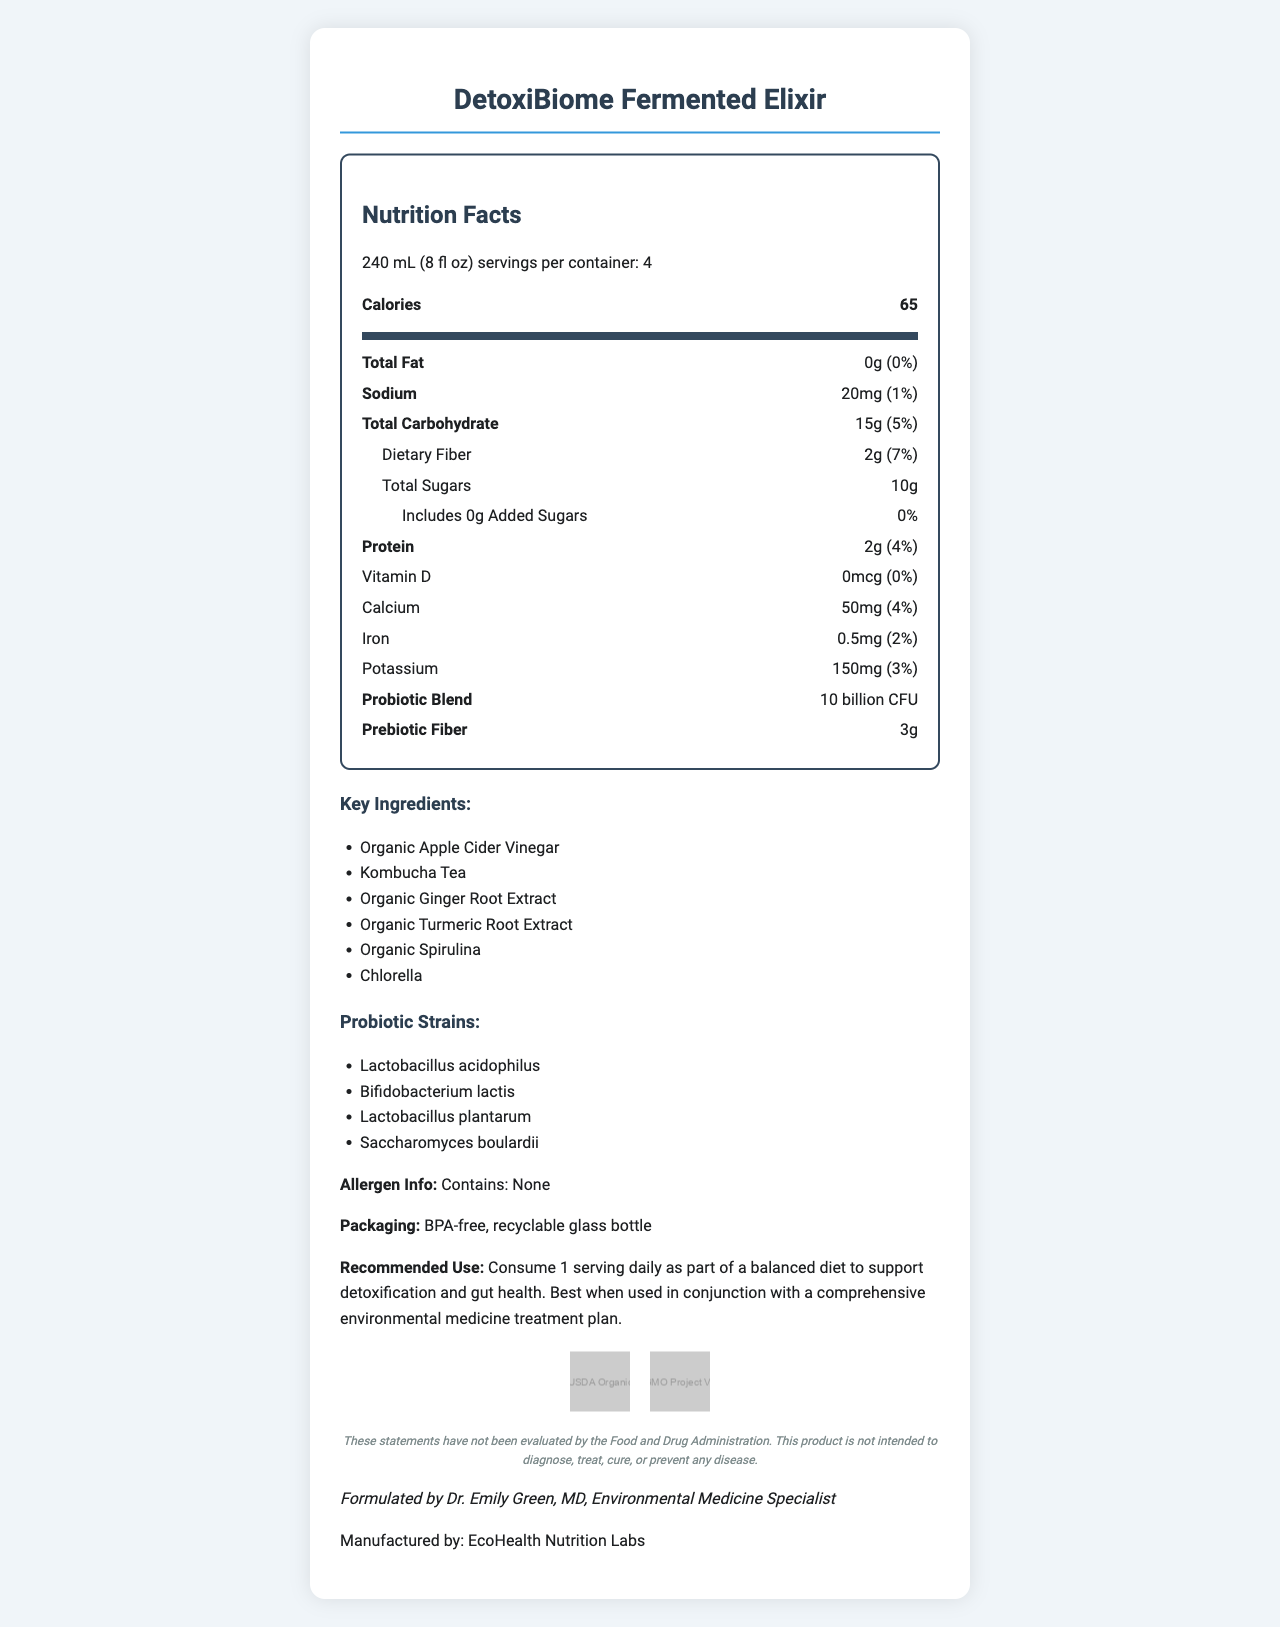what is the serving size? The serving size is listed as "240 mL (8 fl oz)" under the Nutrition Facts section.
Answer: 240 mL (8 fl oz) how many servings are there per container? The document states "servings per container: 4" at the beginning of the Nutrition Facts section.
Answer: 4 how many calories are in one serving? The calories per serving are given as 65.
Answer: 65 what is the amount of total fat per serving? The quantity of total fat per serving is provided as "0g".
Answer: 0g which probiotic strains are included in the blend? The document lists the probiotic strains under the Probiotic Blend section.
Answer: Lactobacillus acidophilus, Bifidobacterium lactis, Lactobacillus plantarum, Saccharomyces boulardii what is the source of prebiotic fiber? A. Inulin (from chicory root) B. Fructooligosaccharides C. Galactooligosaccharides D. Pectin The source of prebiotic fiber is given as "Inulin (from chicory root)".
Answer: A how much dietary fiber is in one serving? A. 1g B. 2g C. 3g D. 4g Each serving contains 2g of dietary fiber.
Answer: B does this product contain any allergens? The allergen information section states "Contains: None".
Answer: No is this product intended to diagnose, treat, cure, or prevent any disease? The disclaimer specifies that the product is not intended to diagnose, treat, cure, or prevent any disease.
Answer: No summarize the key points of the Nutrition Facts Label for "DetoxiBiome Fermented Elixir." This summary captures the primary information from the Nutrition Facts Label, highlighting the key nutritional contents, ingredients, and certifications.
Answer: DetoxiBiome Fermented Elixir is a probiotic-rich fermented beverage that supports detoxification and gut health. It contains 65 calories per 240 mL serving with 4 servings per container. Key nutrients include 2g of protein, 2g of dietary fiber, and 150mg of potassium per serving. The product features a probiotic blend of 10 billion CFU with strains like Lactobacillus acidophilus and Bifidobacterium lactis. It also has 3g of prebiotic fiber sourced from inulin. The beverage is made with organic ingredients and has environmental certifications such as USDA Organic and Non-GMO Project Verified. There are no allergens in the product, and it is packaged in a BPA-free, recyclable glass bottle. what is the exact amount of vitamin D in each serving? The amount of vitamin D per serving is listed as "0mcg".
Answer: 0mcg who formulated the "DetoxiBiome Fermented Elixir"? The physician note specifies that the product was formulated by Dr. Emily Green, MD, Environmental Medicine Specialist.
Answer: Dr. Emily Green, MD what is the main ingredient in DetoxiBiome Fermented Elixir? The document lists several key ingredients but does not specify a main ingredient.
Answer: Not enough information is the packaging environmentally friendly? The information states that the packaging is a BPA-free, recyclable glass bottle, indicating its environmentally friendly nature.
Answer: Yes 